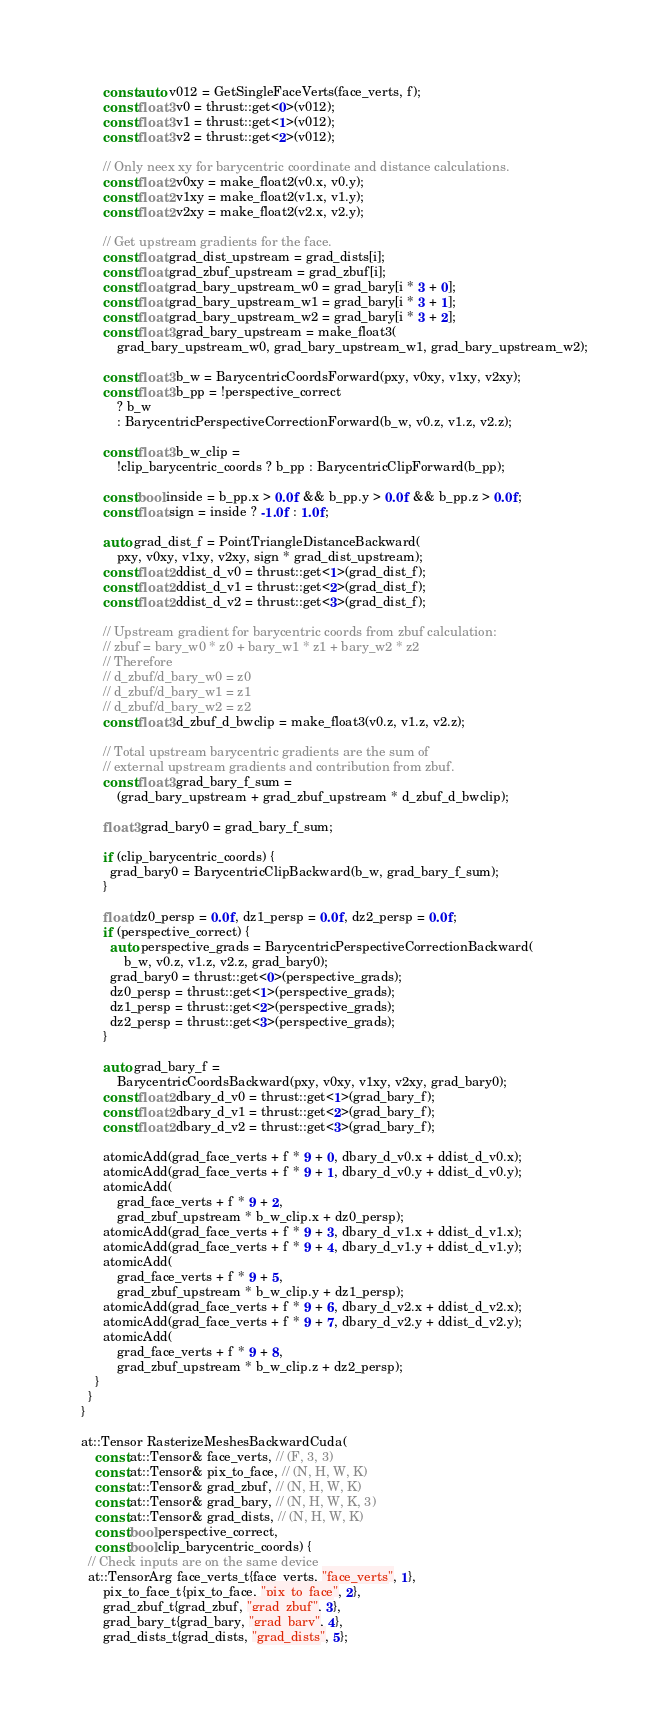<code> <loc_0><loc_0><loc_500><loc_500><_Cuda_>      const auto v012 = GetSingleFaceVerts(face_verts, f);
      const float3 v0 = thrust::get<0>(v012);
      const float3 v1 = thrust::get<1>(v012);
      const float3 v2 = thrust::get<2>(v012);

      // Only neex xy for barycentric coordinate and distance calculations.
      const float2 v0xy = make_float2(v0.x, v0.y);
      const float2 v1xy = make_float2(v1.x, v1.y);
      const float2 v2xy = make_float2(v2.x, v2.y);

      // Get upstream gradients for the face.
      const float grad_dist_upstream = grad_dists[i];
      const float grad_zbuf_upstream = grad_zbuf[i];
      const float grad_bary_upstream_w0 = grad_bary[i * 3 + 0];
      const float grad_bary_upstream_w1 = grad_bary[i * 3 + 1];
      const float grad_bary_upstream_w2 = grad_bary[i * 3 + 2];
      const float3 grad_bary_upstream = make_float3(
          grad_bary_upstream_w0, grad_bary_upstream_w1, grad_bary_upstream_w2);

      const float3 b_w = BarycentricCoordsForward(pxy, v0xy, v1xy, v2xy);
      const float3 b_pp = !perspective_correct
          ? b_w
          : BarycentricPerspectiveCorrectionForward(b_w, v0.z, v1.z, v2.z);

      const float3 b_w_clip =
          !clip_barycentric_coords ? b_pp : BarycentricClipForward(b_pp);

      const bool inside = b_pp.x > 0.0f && b_pp.y > 0.0f && b_pp.z > 0.0f;
      const float sign = inside ? -1.0f : 1.0f;

      auto grad_dist_f = PointTriangleDistanceBackward(
          pxy, v0xy, v1xy, v2xy, sign * grad_dist_upstream);
      const float2 ddist_d_v0 = thrust::get<1>(grad_dist_f);
      const float2 ddist_d_v1 = thrust::get<2>(grad_dist_f);
      const float2 ddist_d_v2 = thrust::get<3>(grad_dist_f);

      // Upstream gradient for barycentric coords from zbuf calculation:
      // zbuf = bary_w0 * z0 + bary_w1 * z1 + bary_w2 * z2
      // Therefore
      // d_zbuf/d_bary_w0 = z0
      // d_zbuf/d_bary_w1 = z1
      // d_zbuf/d_bary_w2 = z2
      const float3 d_zbuf_d_bwclip = make_float3(v0.z, v1.z, v2.z);

      // Total upstream barycentric gradients are the sum of
      // external upstream gradients and contribution from zbuf.
      const float3 grad_bary_f_sum =
          (grad_bary_upstream + grad_zbuf_upstream * d_zbuf_d_bwclip);

      float3 grad_bary0 = grad_bary_f_sum;

      if (clip_barycentric_coords) {
        grad_bary0 = BarycentricClipBackward(b_w, grad_bary_f_sum);
      }

      float dz0_persp = 0.0f, dz1_persp = 0.0f, dz2_persp = 0.0f;
      if (perspective_correct) {
        auto perspective_grads = BarycentricPerspectiveCorrectionBackward(
            b_w, v0.z, v1.z, v2.z, grad_bary0);
        grad_bary0 = thrust::get<0>(perspective_grads);
        dz0_persp = thrust::get<1>(perspective_grads);
        dz1_persp = thrust::get<2>(perspective_grads);
        dz2_persp = thrust::get<3>(perspective_grads);
      }

      auto grad_bary_f =
          BarycentricCoordsBackward(pxy, v0xy, v1xy, v2xy, grad_bary0);
      const float2 dbary_d_v0 = thrust::get<1>(grad_bary_f);
      const float2 dbary_d_v1 = thrust::get<2>(grad_bary_f);
      const float2 dbary_d_v2 = thrust::get<3>(grad_bary_f);

      atomicAdd(grad_face_verts + f * 9 + 0, dbary_d_v0.x + ddist_d_v0.x);
      atomicAdd(grad_face_verts + f * 9 + 1, dbary_d_v0.y + ddist_d_v0.y);
      atomicAdd(
          grad_face_verts + f * 9 + 2,
          grad_zbuf_upstream * b_w_clip.x + dz0_persp);
      atomicAdd(grad_face_verts + f * 9 + 3, dbary_d_v1.x + ddist_d_v1.x);
      atomicAdd(grad_face_verts + f * 9 + 4, dbary_d_v1.y + ddist_d_v1.y);
      atomicAdd(
          grad_face_verts + f * 9 + 5,
          grad_zbuf_upstream * b_w_clip.y + dz1_persp);
      atomicAdd(grad_face_verts + f * 9 + 6, dbary_d_v2.x + ddist_d_v2.x);
      atomicAdd(grad_face_verts + f * 9 + 7, dbary_d_v2.y + ddist_d_v2.y);
      atomicAdd(
          grad_face_verts + f * 9 + 8,
          grad_zbuf_upstream * b_w_clip.z + dz2_persp);
    }
  }
}

at::Tensor RasterizeMeshesBackwardCuda(
    const at::Tensor& face_verts, // (F, 3, 3)
    const at::Tensor& pix_to_face, // (N, H, W, K)
    const at::Tensor& grad_zbuf, // (N, H, W, K)
    const at::Tensor& grad_bary, // (N, H, W, K, 3)
    const at::Tensor& grad_dists, // (N, H, W, K)
    const bool perspective_correct,
    const bool clip_barycentric_coords) {
  // Check inputs are on the same device
  at::TensorArg face_verts_t{face_verts, "face_verts", 1},
      pix_to_face_t{pix_to_face, "pix_to_face", 2},
      grad_zbuf_t{grad_zbuf, "grad_zbuf", 3},
      grad_bary_t{grad_bary, "grad_bary", 4},
      grad_dists_t{grad_dists, "grad_dists", 5};</code> 